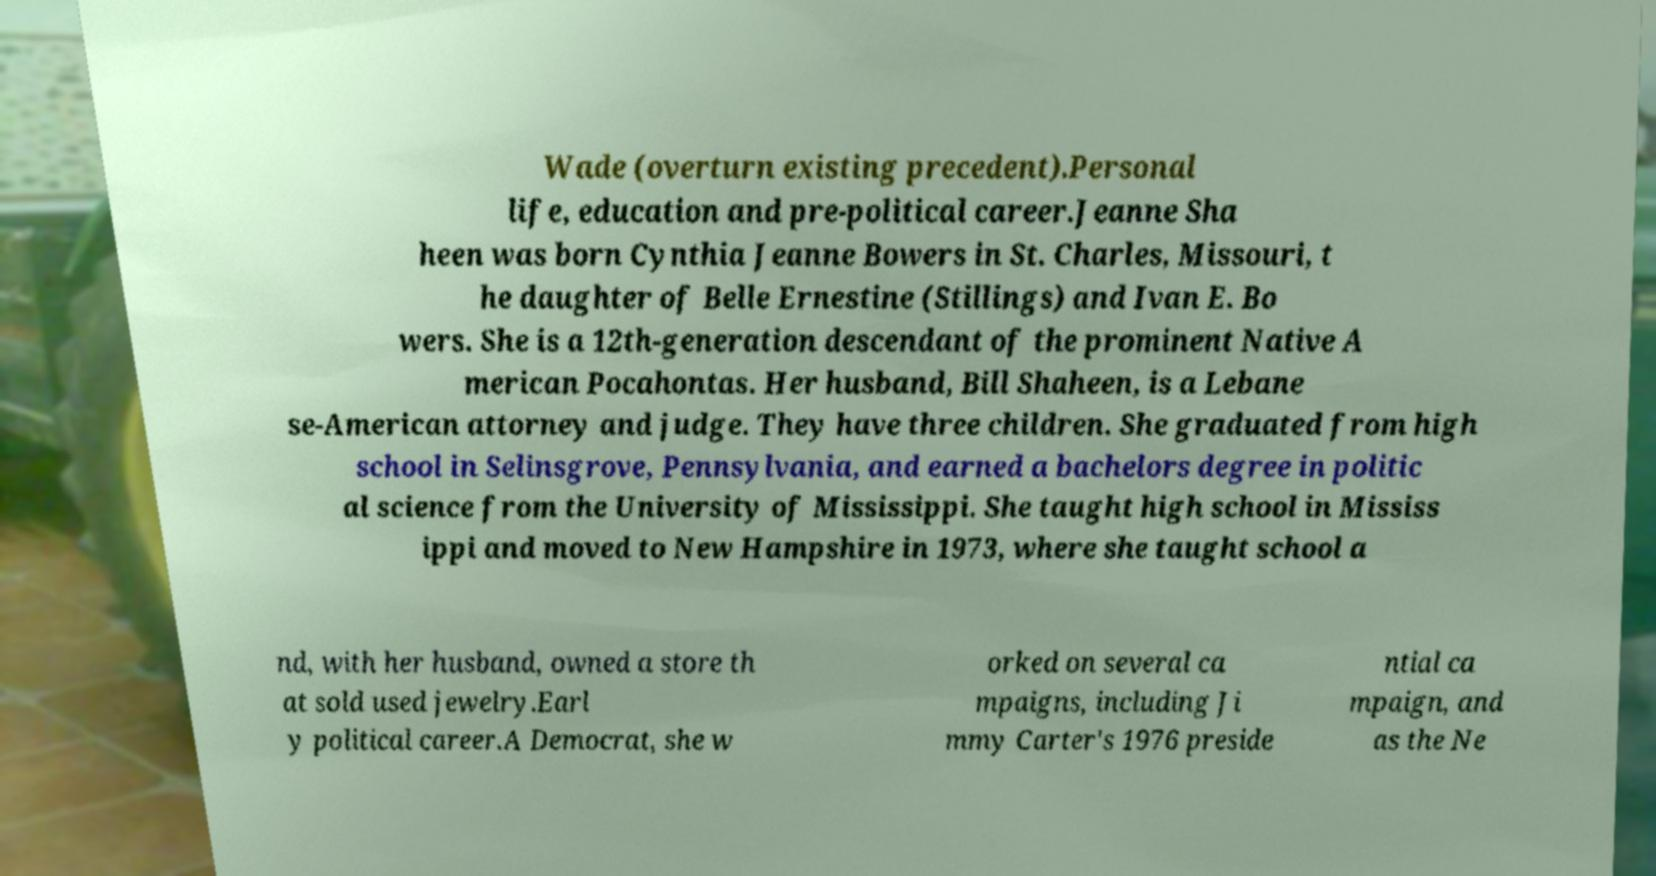Please identify and transcribe the text found in this image. Wade (overturn existing precedent).Personal life, education and pre-political career.Jeanne Sha heen was born Cynthia Jeanne Bowers in St. Charles, Missouri, t he daughter of Belle Ernestine (Stillings) and Ivan E. Bo wers. She is a 12th-generation descendant of the prominent Native A merican Pocahontas. Her husband, Bill Shaheen, is a Lebane se-American attorney and judge. They have three children. She graduated from high school in Selinsgrove, Pennsylvania, and earned a bachelors degree in politic al science from the University of Mississippi. She taught high school in Mississ ippi and moved to New Hampshire in 1973, where she taught school a nd, with her husband, owned a store th at sold used jewelry.Earl y political career.A Democrat, she w orked on several ca mpaigns, including Ji mmy Carter's 1976 preside ntial ca mpaign, and as the Ne 